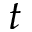<formula> <loc_0><loc_0><loc_500><loc_500>t</formula> 